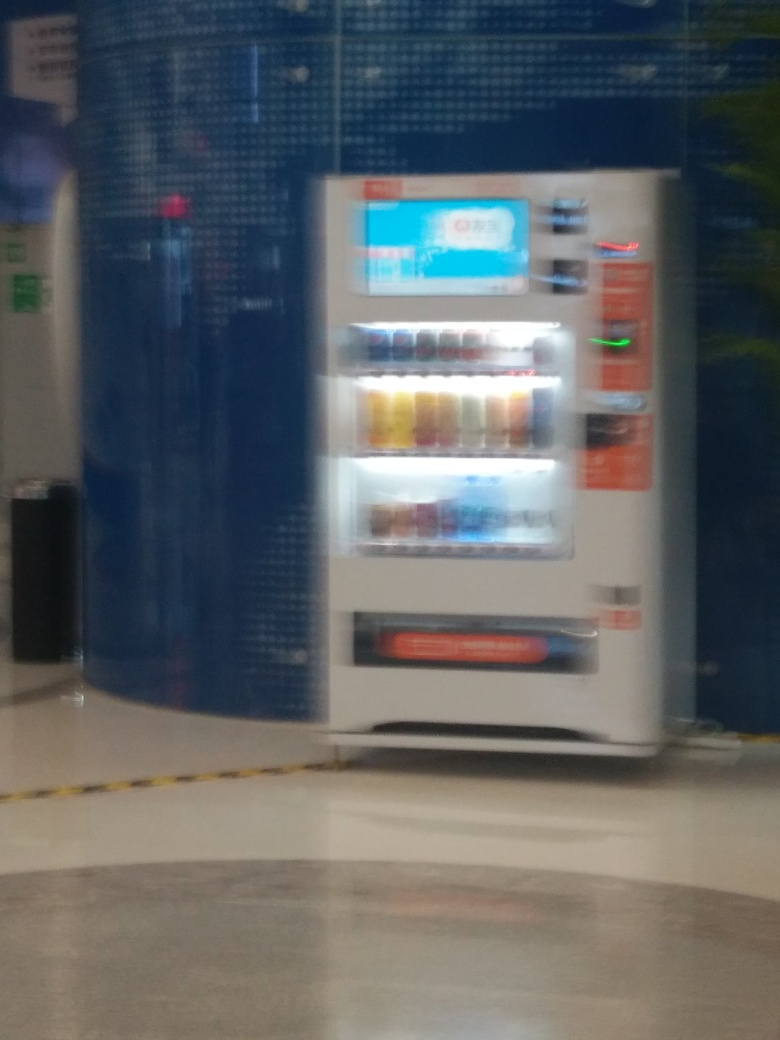Is this vending machine currently being used by anyone? No, in the provided image, there is no one using the vending machine. The area around it appears to be deserted at this moment. 